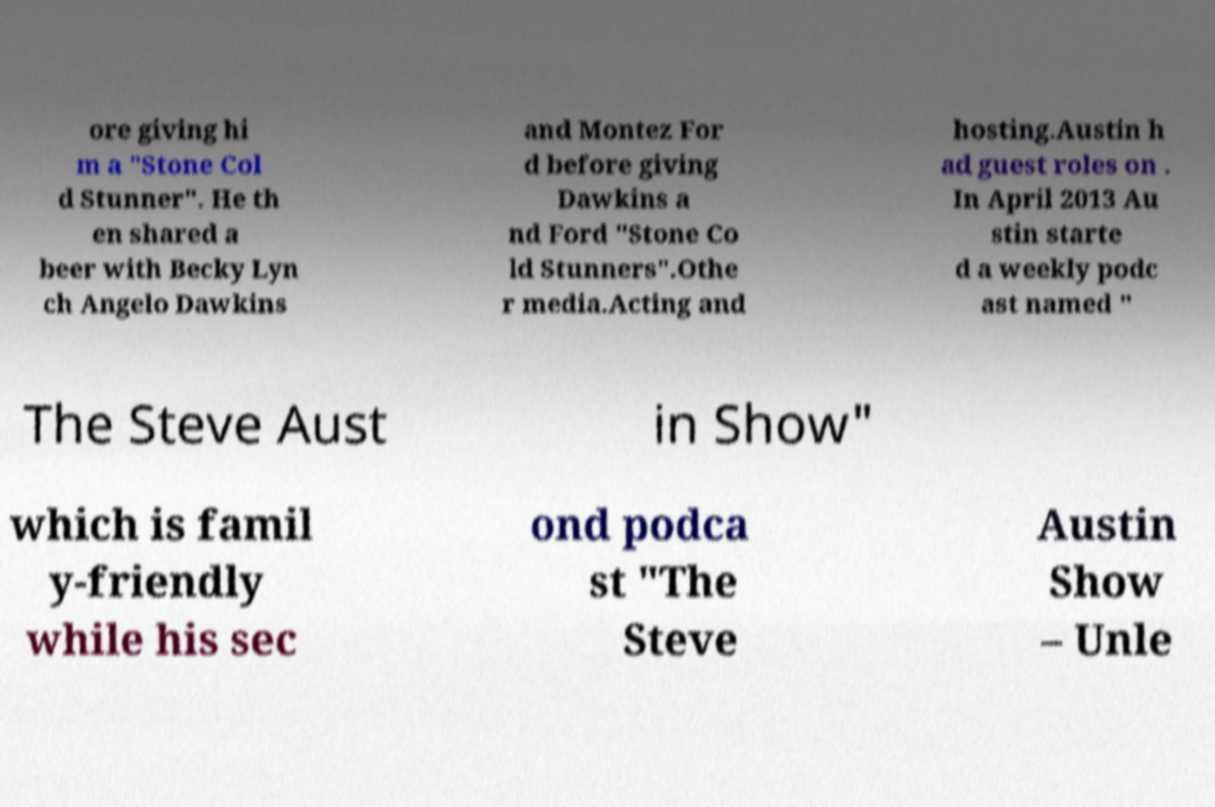There's text embedded in this image that I need extracted. Can you transcribe it verbatim? ore giving hi m a "Stone Col d Stunner". He th en shared a beer with Becky Lyn ch Angelo Dawkins and Montez For d before giving Dawkins a nd Ford "Stone Co ld Stunners".Othe r media.Acting and hosting.Austin h ad guest roles on . In April 2013 Au stin starte d a weekly podc ast named " The Steve Aust in Show" which is famil y-friendly while his sec ond podca st "The Steve Austin Show – Unle 